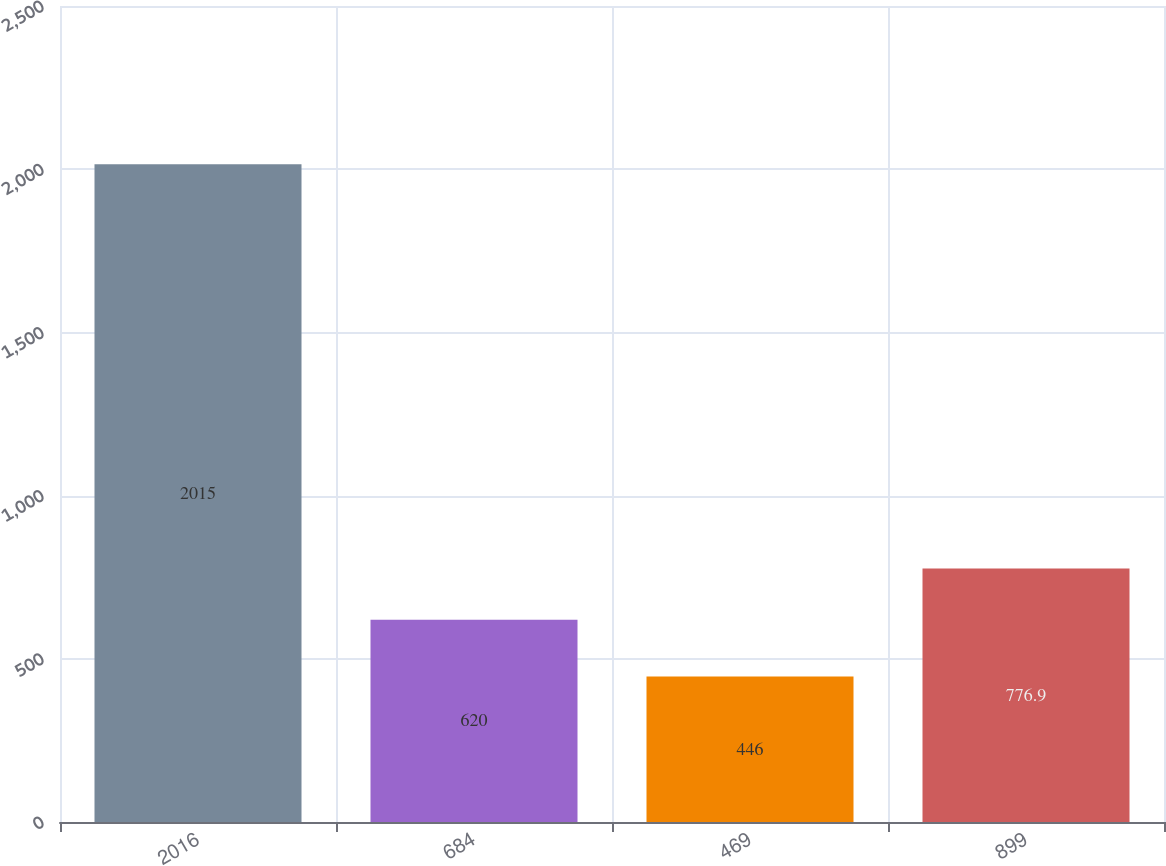Convert chart to OTSL. <chart><loc_0><loc_0><loc_500><loc_500><bar_chart><fcel>2016<fcel>684<fcel>469<fcel>899<nl><fcel>2015<fcel>620<fcel>446<fcel>776.9<nl></chart> 